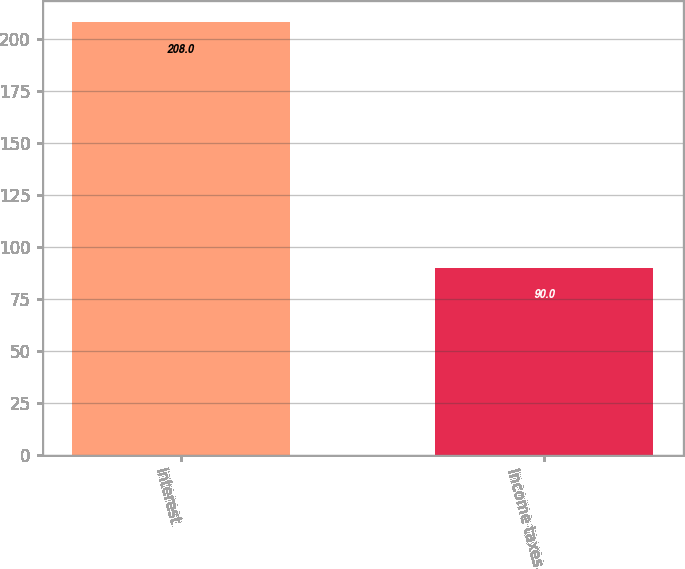Convert chart to OTSL. <chart><loc_0><loc_0><loc_500><loc_500><bar_chart><fcel>Interest<fcel>Income taxes<nl><fcel>208<fcel>90<nl></chart> 